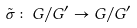Convert formula to latex. <formula><loc_0><loc_0><loc_500><loc_500>\tilde { \sigma } \colon G / G ^ { \prime } \rightarrow G / G ^ { \prime }</formula> 